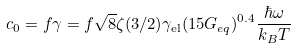Convert formula to latex. <formula><loc_0><loc_0><loc_500><loc_500>c _ { 0 } = f \gamma = f \sqrt { 8 } \zeta ( 3 / 2 ) \gamma _ { \text {el} } ( 1 5 G _ { e q } ) ^ { 0 . 4 } \frac { \hbar { \omega } } { k _ { B } T }</formula> 